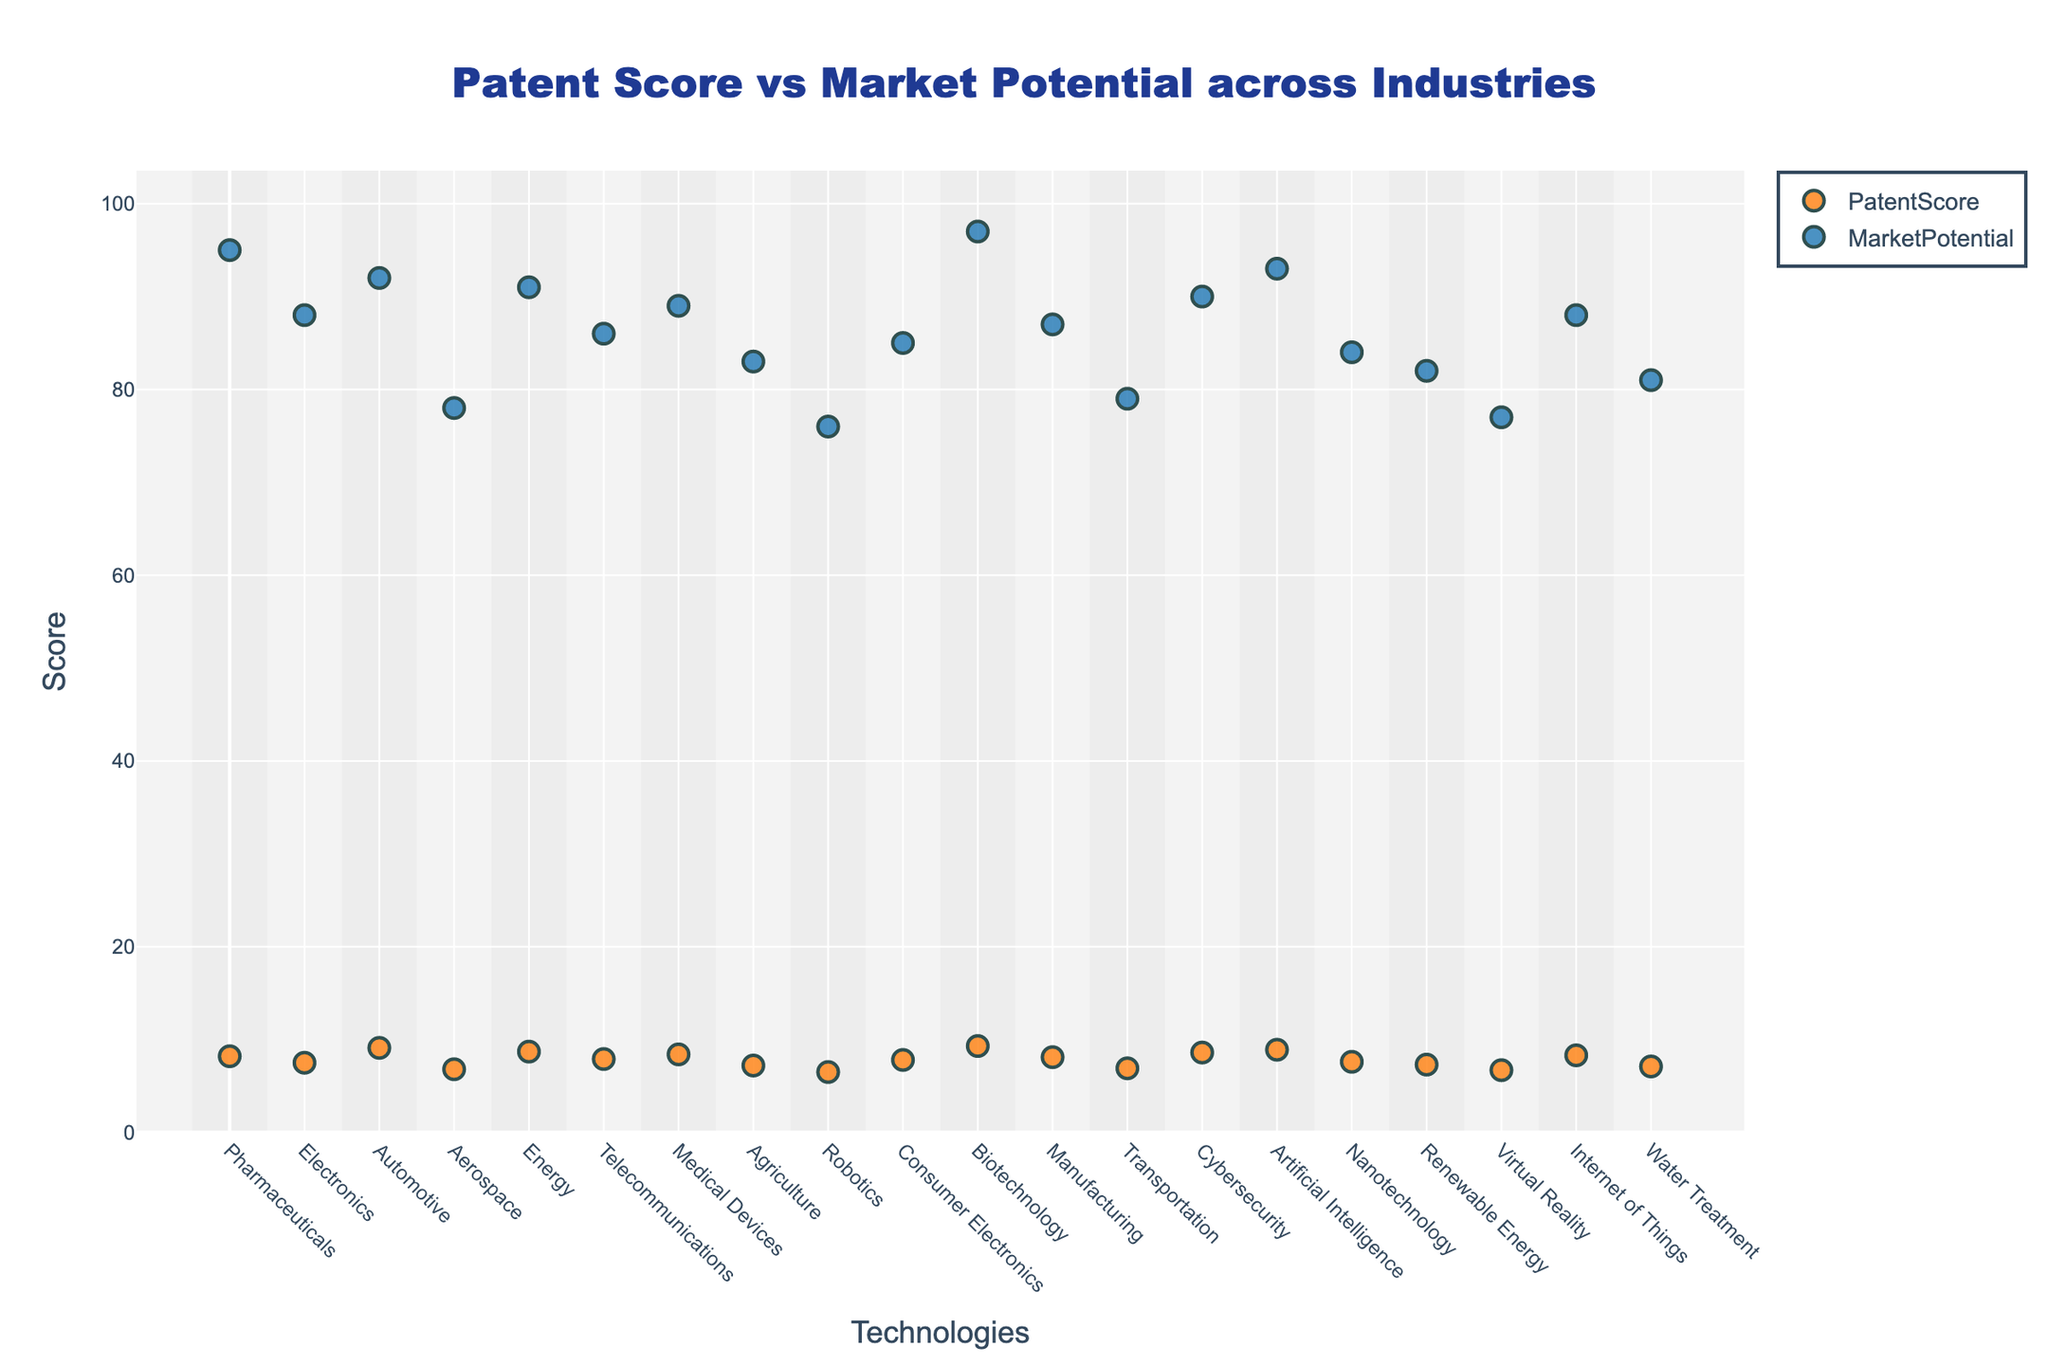Which technology has the highest patent score? To find the technology with the highest patent score, look for the highest point in the scatter plot associated with 'PatentScore'. The y-axis represents the score, and 'PatentScore' is marked with a specific color. Check the hover text for each point to identify the technology.
Answer: mRNA vaccine platforms Which industry has the lowest market potential score? To determine the industry with the lowest market potential score, look for the point with the lowest y-value on the plot associated with 'MarketPotential'. The y-axis represents the score, and 'MarketPotential' points are marked in a specific color. The industry's name can be seen in the hover text.
Answer: Robotics (Soft robotic actuators) What is the difference between the maximum patent score and the minimum patent score? Identify the maximum patent score (9.3) and minimum patent score (6.5) from the plot. Subtract the minimum score from the maximum score to find the difference. 9.3 - 6.5 = 2.8
Answer: 2.8 Are there any industries with both patent score and market potential higher than 90? Examine the figure to find any points where both 'PatentScore' and 'MarketPotential' exceed 90. Remember that each metric is represented by different marks and you need to check the coordinates and hover text for validation.
Answer: Yes, Biotechnology (mRNA vaccine platforms) Which technology in the Artificial Intelligence industry has the highest scores for both patent and market potential? Look into the hover texts for points that belong to the Artificial Intelligence industry. Identify the technology by observing both 'PatentScore' and 'MarketPotential'. There's only one such technology to check.
Answer: Neuromorphic computing What is the average market potential score of the technologies in the Renewable Energy and Energy industries? Find the market potential scores for Advanced wind turbine blades (82) and Perovskite solar cells (91). Calculate the average: (82 + 91) / 2 = 86.5
Answer: 86.5 How does the market potential of Quantum encryption compare to CRISPR gene editing? Identify the market potential scores of Quantum encryption (90) and CRISPR gene editing (95) from the plot. Compare the two values to see which is higher.
Answer: CRISPR gene editing has a higher market potential Which technology has the largest gap between its patent score and market potential? Calculate the absolute difference between 'PatentScore' and 'MarketPotential' for each technology. The technology with the largest gap will have the highest value. Check the point attributes and hover text for each technology.
Answer: CRISPR gene editing (95 - 8.2 = 86.8) Are there any technologies where the market potential is exactly equal to the patent score? Look for points where 'PatentScore' and 'MarketPotential' overlap exactly. Check the coordinates and hover text for each point on the plot to validate.
Answer: No 